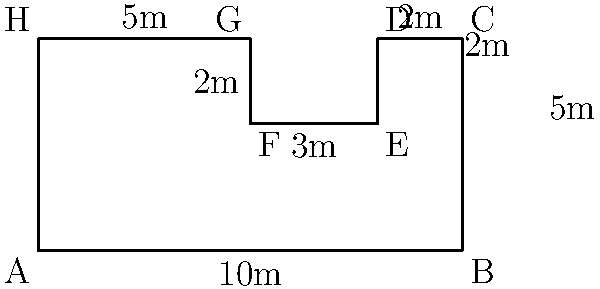As the organizer of local amateur soccer games, you need to determine the area of an irregularly shaped parking lot for game attendees. The lot's shape is shown in the diagram above, with measurements in meters. What is the total area of the parking lot in square meters? To find the area of this irregularly shaped parking lot, we can break it down into rectangles:

1. Main rectangle (ABCH):
   Area = 10m × 5m = 50 m²

2. Small rectangle to be subtracted (DEFG):
   Area = 3m × 2m = 6 m²

3. Total area:
   $$ \text{Total Area} = \text{Main Rectangle} - \text{Small Rectangle} $$
   $$ \text{Total Area} = 50 \text{ m}^2 - 6 \text{ m}^2 = 44 \text{ m}^2 $$

Therefore, the total area of the parking lot is 44 square meters.
Answer: 44 m² 